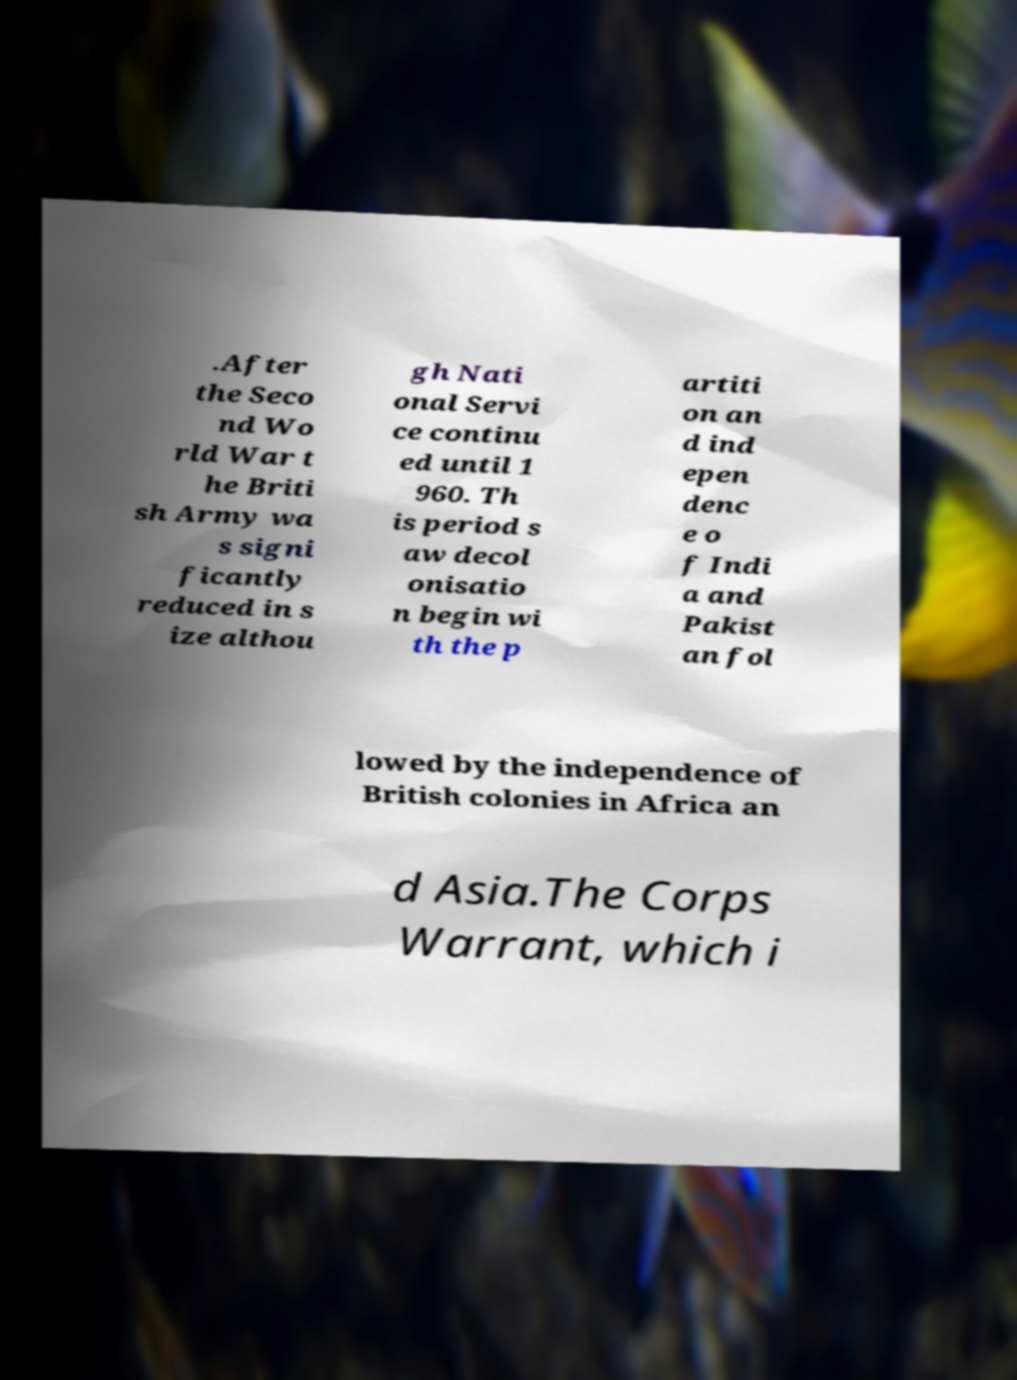Please read and relay the text visible in this image. What does it say? .After the Seco nd Wo rld War t he Briti sh Army wa s signi ficantly reduced in s ize althou gh Nati onal Servi ce continu ed until 1 960. Th is period s aw decol onisatio n begin wi th the p artiti on an d ind epen denc e o f Indi a and Pakist an fol lowed by the independence of British colonies in Africa an d Asia.The Corps Warrant, which i 